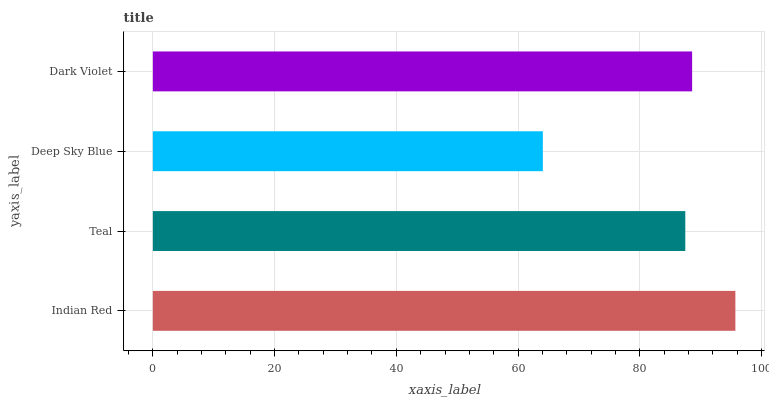Is Deep Sky Blue the minimum?
Answer yes or no. Yes. Is Indian Red the maximum?
Answer yes or no. Yes. Is Teal the minimum?
Answer yes or no. No. Is Teal the maximum?
Answer yes or no. No. Is Indian Red greater than Teal?
Answer yes or no. Yes. Is Teal less than Indian Red?
Answer yes or no. Yes. Is Teal greater than Indian Red?
Answer yes or no. No. Is Indian Red less than Teal?
Answer yes or no. No. Is Dark Violet the high median?
Answer yes or no. Yes. Is Teal the low median?
Answer yes or no. Yes. Is Teal the high median?
Answer yes or no. No. Is Dark Violet the low median?
Answer yes or no. No. 